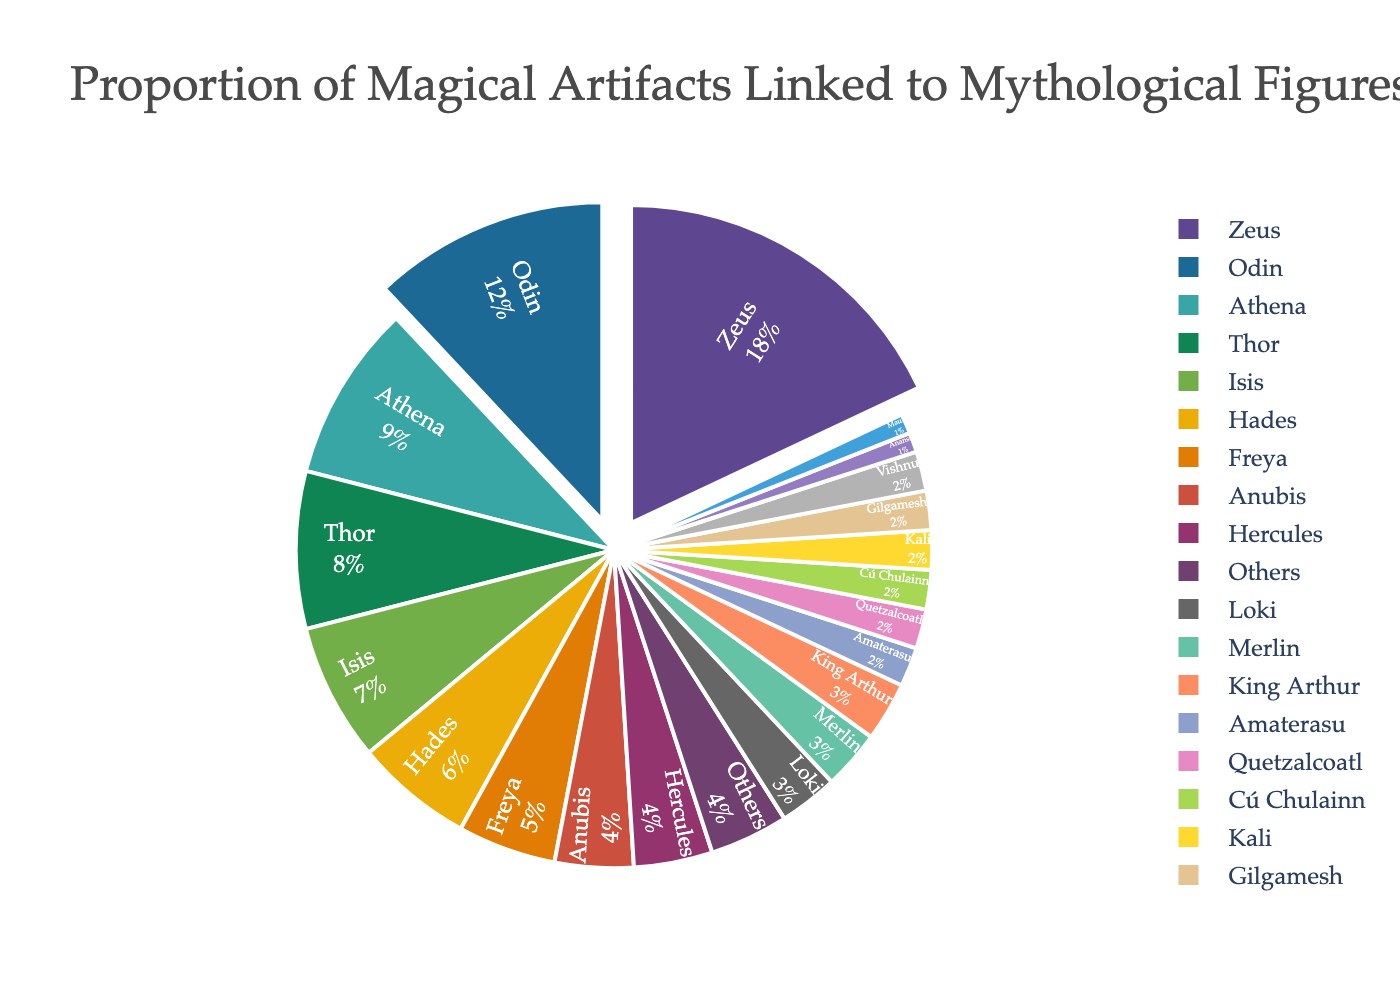Which mythological figure or deity is linked to the highest proportion of magical artifacts? The figure with the largest section in the pie chart indicates the highest proportion. From the chart, this is Zeus at 18%.
Answer: Zeus Which two figures combined have the highest proportion of magical artifacts linked? The top two figures in the pie chart are Zeus (18%) and Odin (12%). Adding these gives the highest combined proportion: 18% + 12% = 30%.
Answer: Zeus and Odin How does Thor compare to Athena in terms of the proportion of magical artifacts linked to them? Thor's section is 8%, while Athena's section is 9%. Comparing these two values, Athena has a slightly higher proportion.
Answer: Athena has a higher proportion What is the combined proportion of artifacts linked to Anubis, Hercules, and Loki? From the pie chart, Anubis has 4%, Hercules has 4%, and Loki has 3%. Summing these up: 4% + 4% + 3% = 11%.
Answer: 11% Which figures have an equal fraction of artifacts linked to them and what is that fraction? Looking at the chart, Anubis, Hercules, and King Arthur each have an equal fraction of 3%.
Answer: Anubis, Hercules, and King Arthur (3%) What's the difference in the proportion of artifacts linked to Freya and Isis? Freya's section of the chart is 5%, and Isis's section is 7%. The difference is 7% - 5% = 2%.
Answer: 2% How does the total proportion of artifacts linked to figures from Norse mythology (Odin, Thor, Freya, Loki) compare with those from Egyptian mythology (Isis, Anubis)? Odin (12%), Thor (8%), Freya (5%), and Loki (3%) together sum to 12% + 8% + 5% + 3% = 28%. Isis (7%) and Anubis (4%) sum to 7% + 4% = 11%. Thus, Norse figures combined have a higher proportion than Egyptian figures.
Answer: Norse figures have a higher proportion What proportion of the artifacts are linked to figures that each have less than or equal to 2%? Amaterasu, Quetzalcoatl, Cú Chulainn, Kali, Gilgamesh, Vishnu, Anansi, Maui, and Others each have 2% or less. Summing these values: 2% + 2% + 2% + 2% + 2% + 2% + 1% + 1% + 4% = 18%.
Answer: 18% If you combine Zeus's proportion with that of figures having 5% or less, what is the total percentage? Zeus's proportion is 18%. Figures with 5% or less are: Freya (5%), Anubis (4%), Hercules (4%), Loki (3%), Merlin (3%), King Arthur (3%), Amaterasu (2%), Quetzalcoatl (2%), Cú Chulainn (2%), Kali (2%), Gilgamesh (2%), Vishnu (2%), Anansi (1%), Maui (1%), and Others (4%). Summing these: 18% + 5% + 4% + 4% +3% + 3% + 3% + 2% + 2% + 2% + 2% + 2% + 2% + 1% + 1% + 4% = 60%.
Answer: 60% 